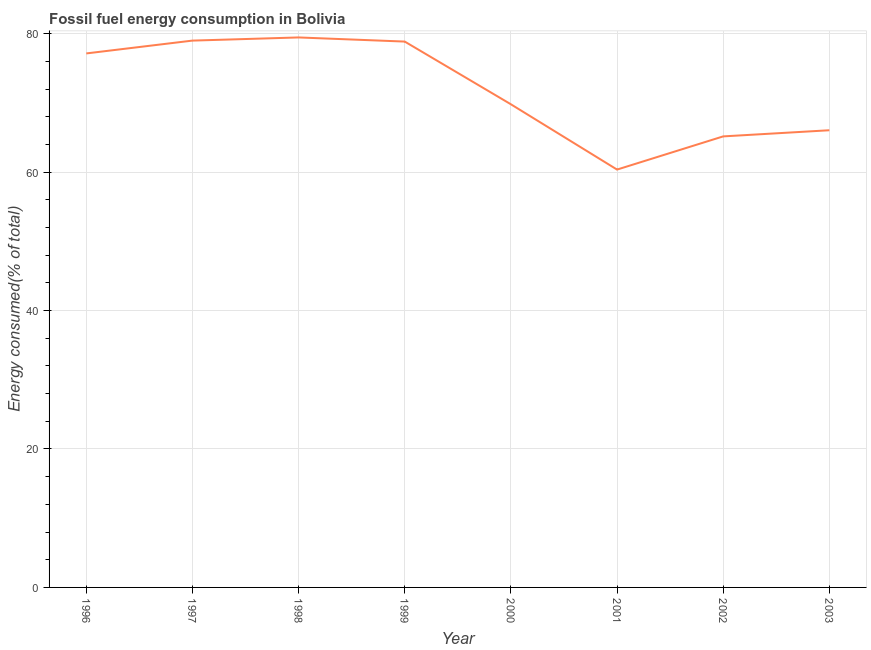What is the fossil fuel energy consumption in 2001?
Ensure brevity in your answer.  60.37. Across all years, what is the maximum fossil fuel energy consumption?
Make the answer very short. 79.46. Across all years, what is the minimum fossil fuel energy consumption?
Offer a terse response. 60.37. In which year was the fossil fuel energy consumption minimum?
Offer a very short reply. 2001. What is the sum of the fossil fuel energy consumption?
Your answer should be compact. 575.84. What is the difference between the fossil fuel energy consumption in 2001 and 2002?
Offer a terse response. -4.79. What is the average fossil fuel energy consumption per year?
Provide a short and direct response. 71.98. What is the median fossil fuel energy consumption?
Your response must be concise. 73.47. In how many years, is the fossil fuel energy consumption greater than 8 %?
Provide a short and direct response. 8. Do a majority of the years between 2001 and 1997 (inclusive) have fossil fuel energy consumption greater than 64 %?
Offer a very short reply. Yes. What is the ratio of the fossil fuel energy consumption in 1996 to that in 2002?
Make the answer very short. 1.18. Is the fossil fuel energy consumption in 1996 less than that in 1999?
Your response must be concise. Yes. Is the difference between the fossil fuel energy consumption in 2000 and 2003 greater than the difference between any two years?
Ensure brevity in your answer.  No. What is the difference between the highest and the second highest fossil fuel energy consumption?
Offer a very short reply. 0.46. Is the sum of the fossil fuel energy consumption in 1996 and 2002 greater than the maximum fossil fuel energy consumption across all years?
Make the answer very short. Yes. What is the difference between the highest and the lowest fossil fuel energy consumption?
Provide a succinct answer. 19.09. Does the fossil fuel energy consumption monotonically increase over the years?
Give a very brief answer. No. Are the values on the major ticks of Y-axis written in scientific E-notation?
Make the answer very short. No. Does the graph contain any zero values?
Provide a succinct answer. No. Does the graph contain grids?
Ensure brevity in your answer.  Yes. What is the title of the graph?
Your response must be concise. Fossil fuel energy consumption in Bolivia. What is the label or title of the X-axis?
Your answer should be very brief. Year. What is the label or title of the Y-axis?
Offer a very short reply. Energy consumed(% of total). What is the Energy consumed(% of total) of 1996?
Your answer should be compact. 77.15. What is the Energy consumed(% of total) in 1997?
Your response must be concise. 79. What is the Energy consumed(% of total) in 1998?
Your answer should be very brief. 79.46. What is the Energy consumed(% of total) in 1999?
Your answer should be compact. 78.86. What is the Energy consumed(% of total) in 2000?
Provide a succinct answer. 69.8. What is the Energy consumed(% of total) in 2001?
Your answer should be compact. 60.37. What is the Energy consumed(% of total) of 2002?
Ensure brevity in your answer.  65.16. What is the Energy consumed(% of total) of 2003?
Offer a terse response. 66.05. What is the difference between the Energy consumed(% of total) in 1996 and 1997?
Your answer should be very brief. -1.85. What is the difference between the Energy consumed(% of total) in 1996 and 1998?
Provide a short and direct response. -2.31. What is the difference between the Energy consumed(% of total) in 1996 and 1999?
Your answer should be compact. -1.71. What is the difference between the Energy consumed(% of total) in 1996 and 2000?
Offer a very short reply. 7.35. What is the difference between the Energy consumed(% of total) in 1996 and 2001?
Give a very brief answer. 16.78. What is the difference between the Energy consumed(% of total) in 1996 and 2002?
Offer a terse response. 11.99. What is the difference between the Energy consumed(% of total) in 1996 and 2003?
Give a very brief answer. 11.1. What is the difference between the Energy consumed(% of total) in 1997 and 1998?
Your answer should be very brief. -0.46. What is the difference between the Energy consumed(% of total) in 1997 and 1999?
Provide a short and direct response. 0.14. What is the difference between the Energy consumed(% of total) in 1997 and 2000?
Offer a very short reply. 9.2. What is the difference between the Energy consumed(% of total) in 1997 and 2001?
Keep it short and to the point. 18.63. What is the difference between the Energy consumed(% of total) in 1997 and 2002?
Keep it short and to the point. 13.84. What is the difference between the Energy consumed(% of total) in 1997 and 2003?
Offer a terse response. 12.95. What is the difference between the Energy consumed(% of total) in 1998 and 1999?
Make the answer very short. 0.6. What is the difference between the Energy consumed(% of total) in 1998 and 2000?
Keep it short and to the point. 9.66. What is the difference between the Energy consumed(% of total) in 1998 and 2001?
Provide a succinct answer. 19.09. What is the difference between the Energy consumed(% of total) in 1998 and 2002?
Your answer should be compact. 14.3. What is the difference between the Energy consumed(% of total) in 1998 and 2003?
Keep it short and to the point. 13.41. What is the difference between the Energy consumed(% of total) in 1999 and 2000?
Your response must be concise. 9.06. What is the difference between the Energy consumed(% of total) in 1999 and 2001?
Ensure brevity in your answer.  18.49. What is the difference between the Energy consumed(% of total) in 1999 and 2002?
Provide a succinct answer. 13.7. What is the difference between the Energy consumed(% of total) in 1999 and 2003?
Your response must be concise. 12.81. What is the difference between the Energy consumed(% of total) in 2000 and 2001?
Make the answer very short. 9.43. What is the difference between the Energy consumed(% of total) in 2000 and 2002?
Your answer should be very brief. 4.64. What is the difference between the Energy consumed(% of total) in 2000 and 2003?
Keep it short and to the point. 3.75. What is the difference between the Energy consumed(% of total) in 2001 and 2002?
Provide a succinct answer. -4.79. What is the difference between the Energy consumed(% of total) in 2001 and 2003?
Offer a very short reply. -5.68. What is the difference between the Energy consumed(% of total) in 2002 and 2003?
Offer a very short reply. -0.89. What is the ratio of the Energy consumed(% of total) in 1996 to that in 2000?
Your answer should be very brief. 1.1. What is the ratio of the Energy consumed(% of total) in 1996 to that in 2001?
Offer a very short reply. 1.28. What is the ratio of the Energy consumed(% of total) in 1996 to that in 2002?
Make the answer very short. 1.18. What is the ratio of the Energy consumed(% of total) in 1996 to that in 2003?
Give a very brief answer. 1.17. What is the ratio of the Energy consumed(% of total) in 1997 to that in 1998?
Provide a short and direct response. 0.99. What is the ratio of the Energy consumed(% of total) in 1997 to that in 1999?
Offer a terse response. 1. What is the ratio of the Energy consumed(% of total) in 1997 to that in 2000?
Your answer should be very brief. 1.13. What is the ratio of the Energy consumed(% of total) in 1997 to that in 2001?
Give a very brief answer. 1.31. What is the ratio of the Energy consumed(% of total) in 1997 to that in 2002?
Make the answer very short. 1.21. What is the ratio of the Energy consumed(% of total) in 1997 to that in 2003?
Offer a terse response. 1.2. What is the ratio of the Energy consumed(% of total) in 1998 to that in 2000?
Offer a very short reply. 1.14. What is the ratio of the Energy consumed(% of total) in 1998 to that in 2001?
Give a very brief answer. 1.32. What is the ratio of the Energy consumed(% of total) in 1998 to that in 2002?
Provide a succinct answer. 1.22. What is the ratio of the Energy consumed(% of total) in 1998 to that in 2003?
Provide a succinct answer. 1.2. What is the ratio of the Energy consumed(% of total) in 1999 to that in 2000?
Your answer should be very brief. 1.13. What is the ratio of the Energy consumed(% of total) in 1999 to that in 2001?
Make the answer very short. 1.31. What is the ratio of the Energy consumed(% of total) in 1999 to that in 2002?
Offer a very short reply. 1.21. What is the ratio of the Energy consumed(% of total) in 1999 to that in 2003?
Your response must be concise. 1.19. What is the ratio of the Energy consumed(% of total) in 2000 to that in 2001?
Provide a succinct answer. 1.16. What is the ratio of the Energy consumed(% of total) in 2000 to that in 2002?
Make the answer very short. 1.07. What is the ratio of the Energy consumed(% of total) in 2000 to that in 2003?
Provide a short and direct response. 1.06. What is the ratio of the Energy consumed(% of total) in 2001 to that in 2002?
Keep it short and to the point. 0.93. What is the ratio of the Energy consumed(% of total) in 2001 to that in 2003?
Offer a very short reply. 0.91. 